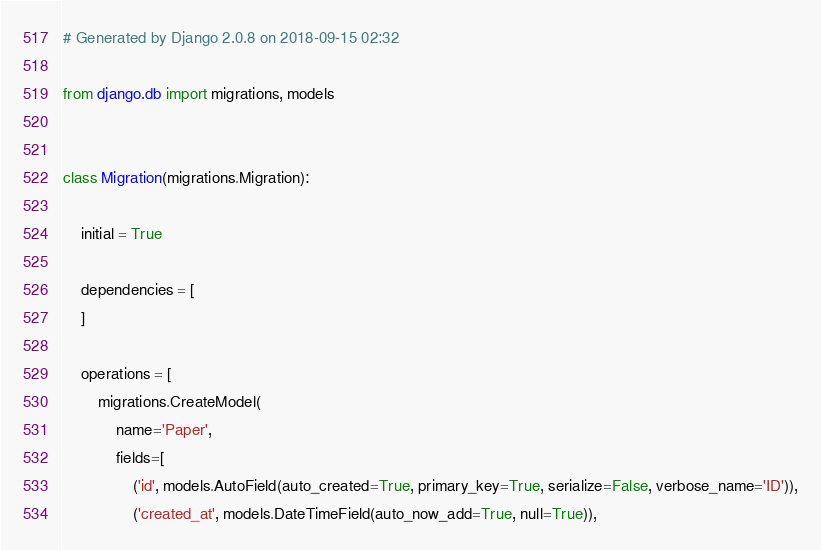<code> <loc_0><loc_0><loc_500><loc_500><_Python_># Generated by Django 2.0.8 on 2018-09-15 02:32

from django.db import migrations, models


class Migration(migrations.Migration):

    initial = True

    dependencies = [
    ]

    operations = [
        migrations.CreateModel(
            name='Paper',
            fields=[
                ('id', models.AutoField(auto_created=True, primary_key=True, serialize=False, verbose_name='ID')),
                ('created_at', models.DateTimeField(auto_now_add=True, null=True)),</code> 